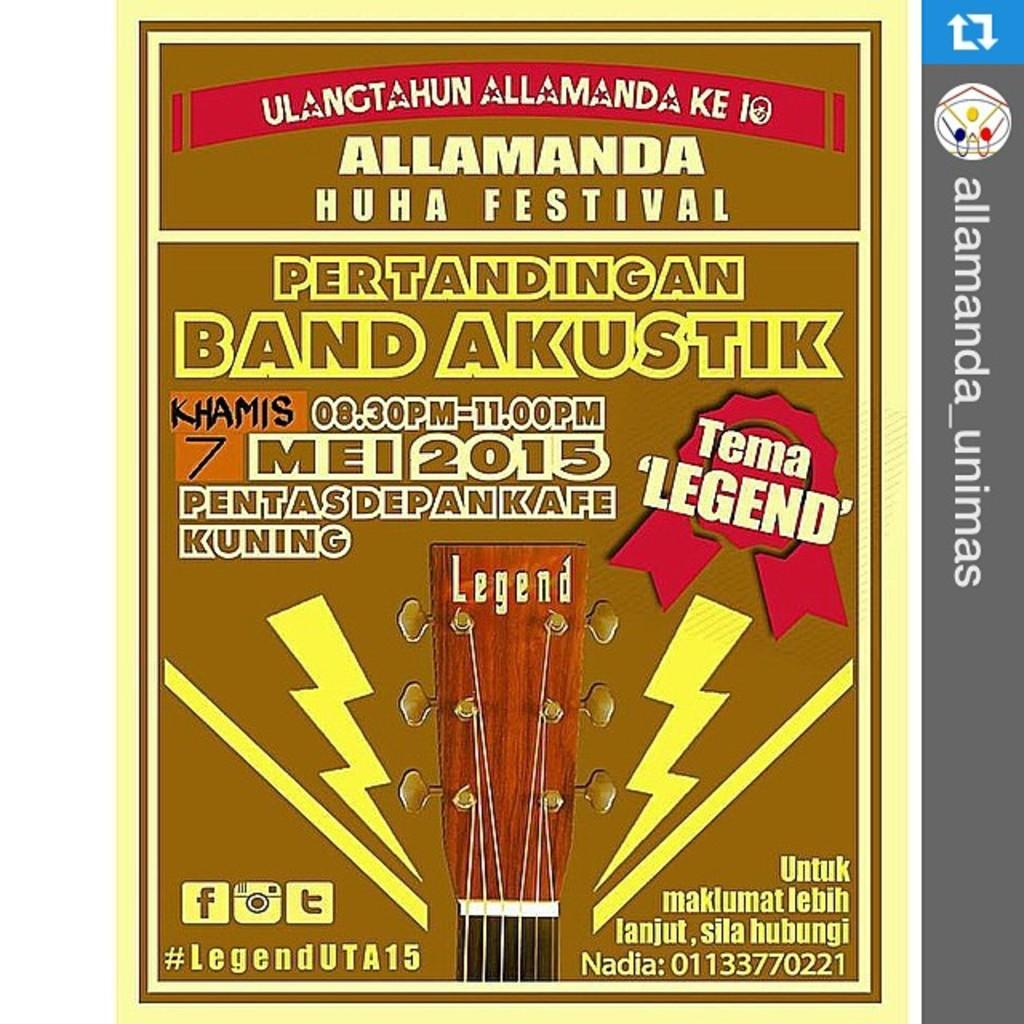<image>
Describe the image concisely. The poster is advertising a festival in Allamanda. 